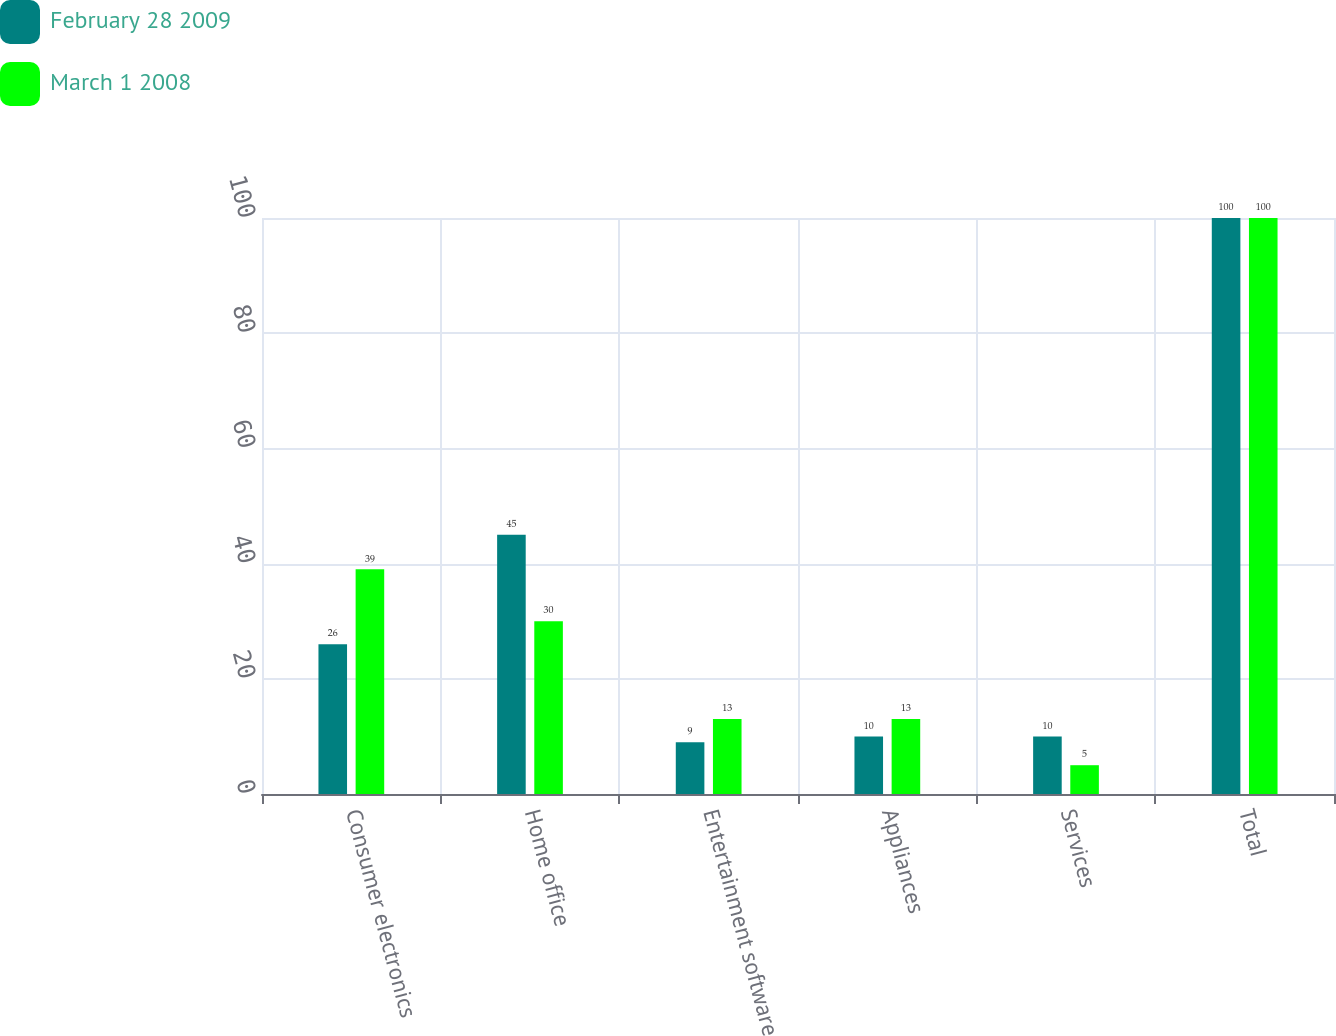Convert chart. <chart><loc_0><loc_0><loc_500><loc_500><stacked_bar_chart><ecel><fcel>Consumer electronics<fcel>Home office<fcel>Entertainment software<fcel>Appliances<fcel>Services<fcel>Total<nl><fcel>February 28 2009<fcel>26<fcel>45<fcel>9<fcel>10<fcel>10<fcel>100<nl><fcel>March 1 2008<fcel>39<fcel>30<fcel>13<fcel>13<fcel>5<fcel>100<nl></chart> 